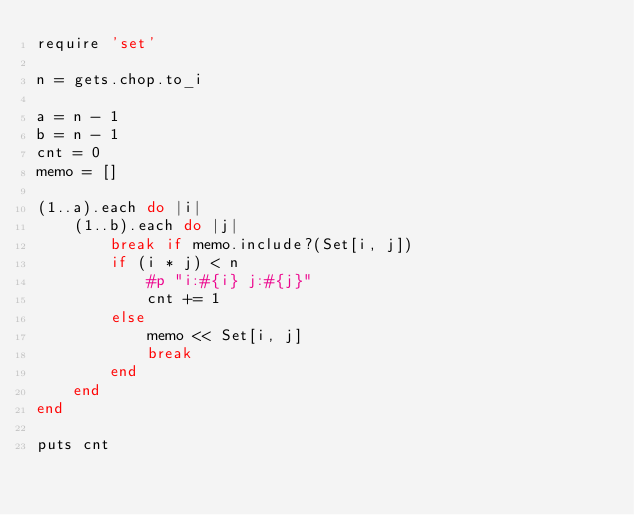<code> <loc_0><loc_0><loc_500><loc_500><_Ruby_>require 'set'

n = gets.chop.to_i

a = n - 1
b = n - 1
cnt = 0
memo = []

(1..a).each do |i|
    (1..b).each do |j|
        break if memo.include?(Set[i, j])
        if (i * j) < n
            #p "i:#{i} j:#{j}"
            cnt += 1
        else
            memo << Set[i, j]
            break
        end
    end
end

puts cnt</code> 